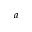Convert formula to latex. <formula><loc_0><loc_0><loc_500><loc_500>^ { a }</formula> 